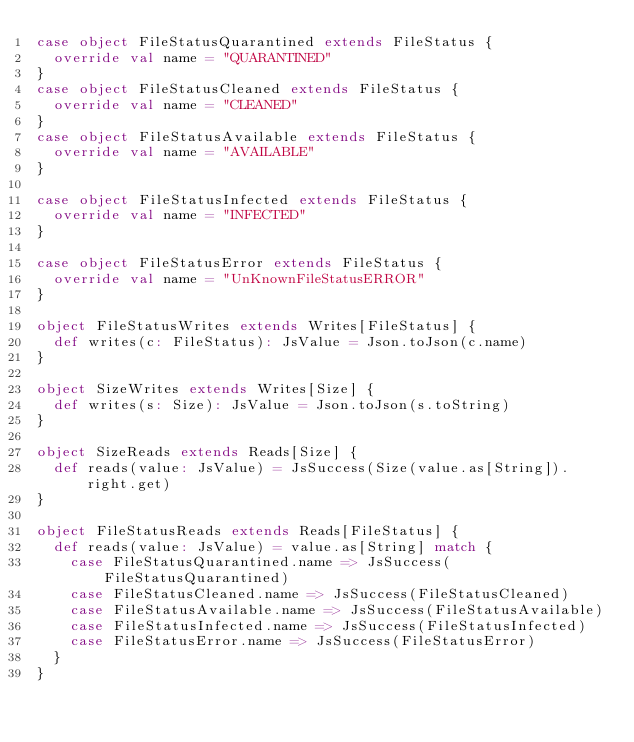Convert code to text. <code><loc_0><loc_0><loc_500><loc_500><_Scala_>case object FileStatusQuarantined extends FileStatus {
  override val name = "QUARANTINED"
}
case object FileStatusCleaned extends FileStatus {
  override val name = "CLEANED"
}
case object FileStatusAvailable extends FileStatus {
  override val name = "AVAILABLE"
}

case object FileStatusInfected extends FileStatus {
  override val name = "INFECTED"
}

case object FileStatusError extends FileStatus {
  override val name = "UnKnownFileStatusERROR"
}

object FileStatusWrites extends Writes[FileStatus] {
  def writes(c: FileStatus): JsValue = Json.toJson(c.name)
}

object SizeWrites extends Writes[Size] {
  def writes(s: Size): JsValue = Json.toJson(s.toString)
}

object SizeReads extends Reads[Size] {
  def reads(value: JsValue) = JsSuccess(Size(value.as[String]).right.get)
}

object FileStatusReads extends Reads[FileStatus] {
  def reads(value: JsValue) = value.as[String] match {
    case FileStatusQuarantined.name => JsSuccess(FileStatusQuarantined)
    case FileStatusCleaned.name => JsSuccess(FileStatusCleaned)
    case FileStatusAvailable.name => JsSuccess(FileStatusAvailable)
    case FileStatusInfected.name => JsSuccess(FileStatusInfected)
    case FileStatusError.name => JsSuccess(FileStatusError)
  }
}
</code> 